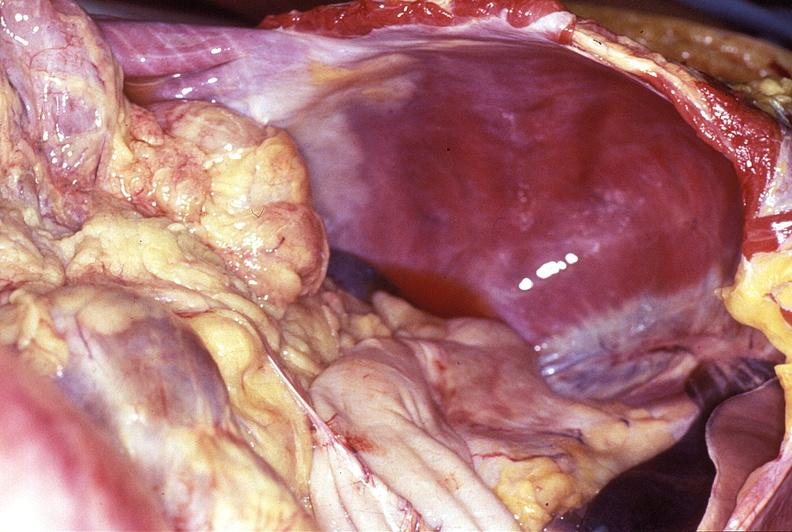what is present?
Answer the question using a single word or phrase. Gastrointestinal 